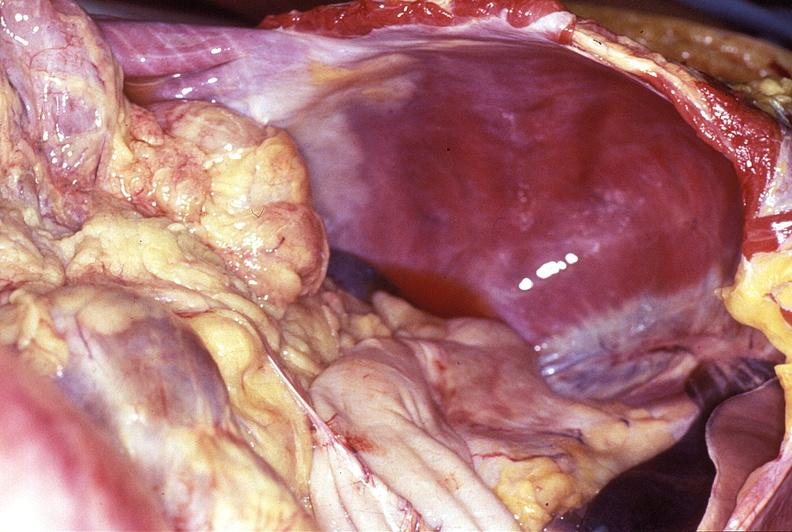what is present?
Answer the question using a single word or phrase. Gastrointestinal 